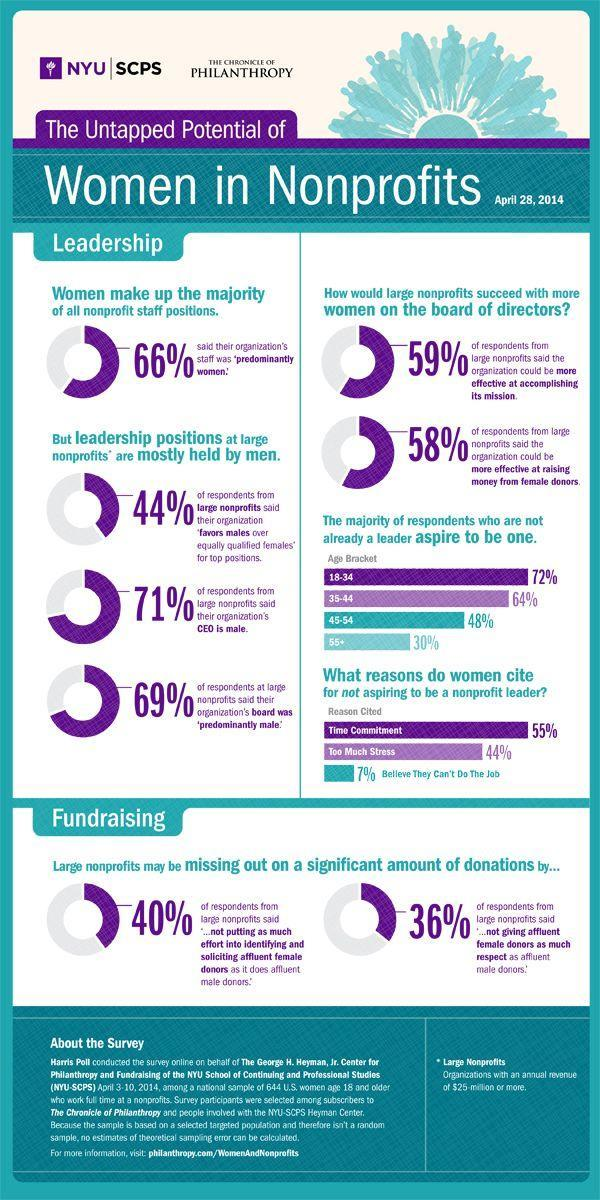What amount of top-level management is owned by men?
Answer the question with a short phrase. 44% 